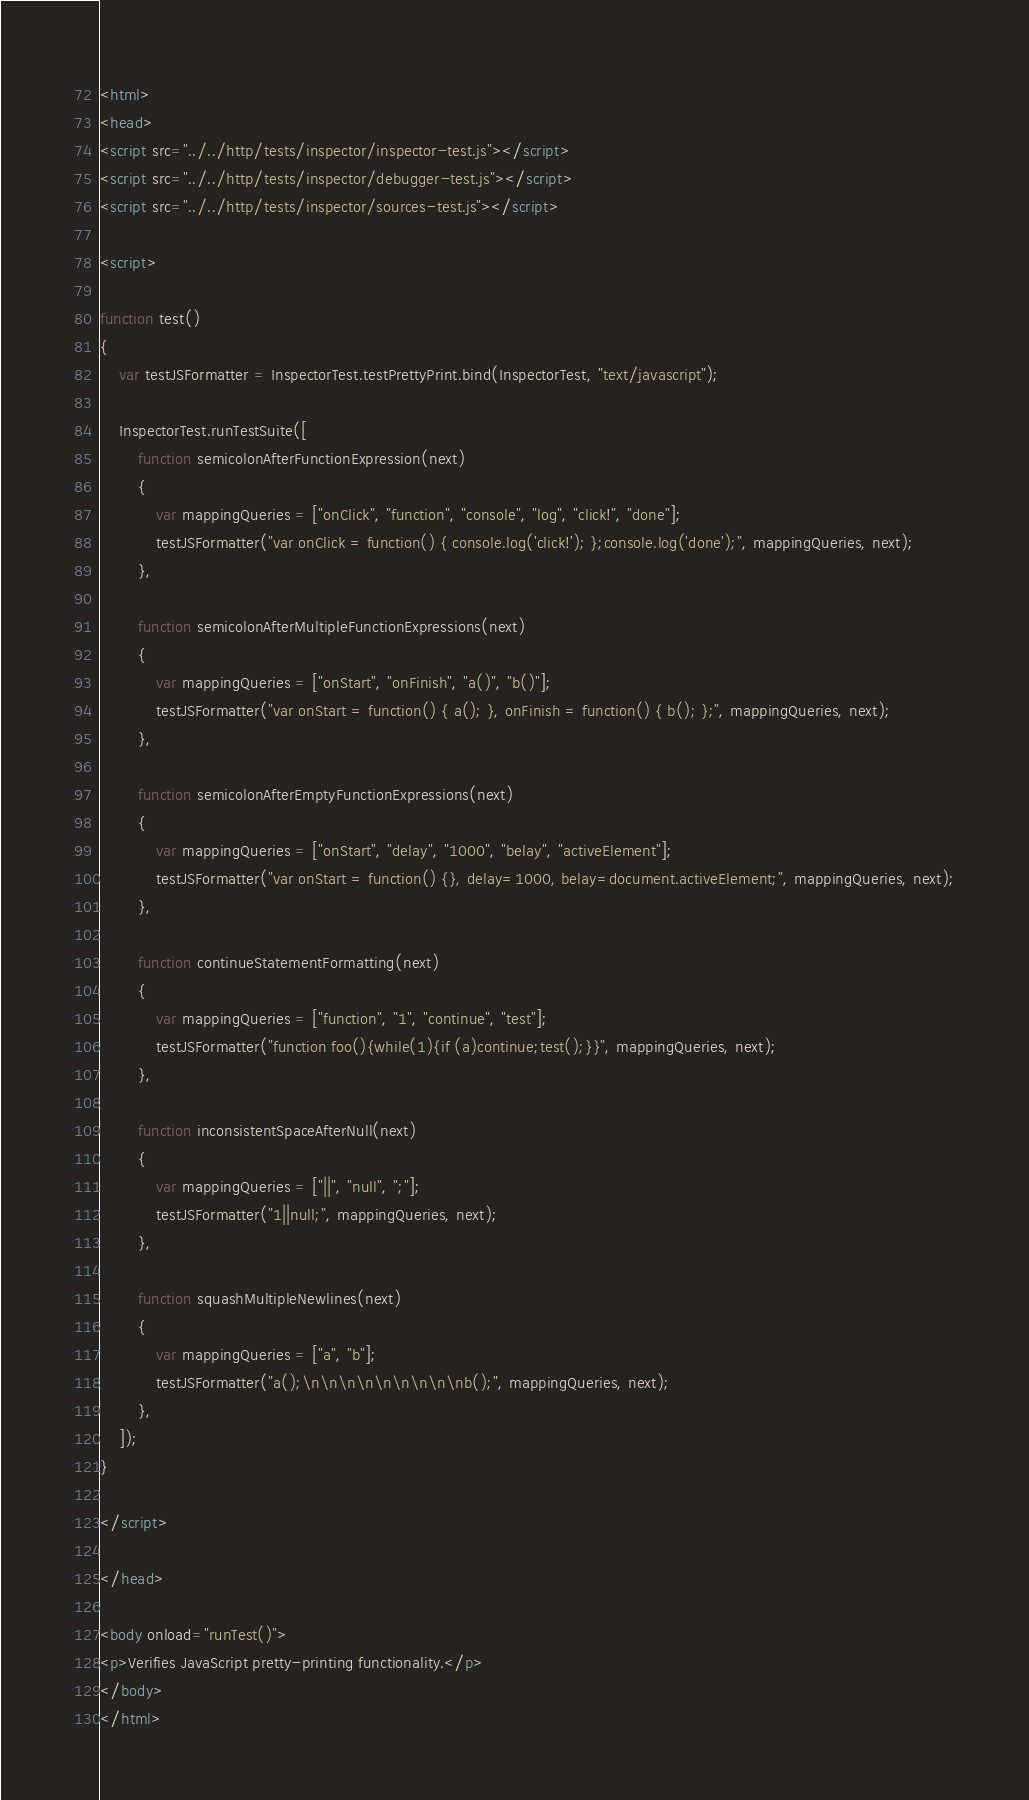<code> <loc_0><loc_0><loc_500><loc_500><_HTML_><html>
<head>
<script src="../../http/tests/inspector/inspector-test.js"></script>
<script src="../../http/tests/inspector/debugger-test.js"></script>
<script src="../../http/tests/inspector/sources-test.js"></script>

<script>

function test()
{
    var testJSFormatter = InspectorTest.testPrettyPrint.bind(InspectorTest, "text/javascript");

    InspectorTest.runTestSuite([
        function semicolonAfterFunctionExpression(next)
        {
            var mappingQueries = ["onClick", "function", "console", "log", "click!", "done"];
            testJSFormatter("var onClick = function() { console.log('click!'); };console.log('done');", mappingQueries, next);
        },

        function semicolonAfterMultipleFunctionExpressions(next)
        {
            var mappingQueries = ["onStart", "onFinish", "a()", "b()"];
            testJSFormatter("var onStart = function() { a(); }, onFinish = function() { b(); };", mappingQueries, next);
        },

        function semicolonAfterEmptyFunctionExpressions(next)
        {
            var mappingQueries = ["onStart", "delay", "1000", "belay", "activeElement"];
            testJSFormatter("var onStart = function() {}, delay=1000, belay=document.activeElement;", mappingQueries, next);
        },

        function continueStatementFormatting(next)
        {
            var mappingQueries = ["function", "1", "continue", "test"];
            testJSFormatter("function foo(){while(1){if (a)continue;test();}}", mappingQueries, next);
        },

        function inconsistentSpaceAfterNull(next)
        {
            var mappingQueries = ["||", "null", ";"];
            testJSFormatter("1||null;", mappingQueries, next);
        },

        function squashMultipleNewlines(next)
        {
            var mappingQueries = ["a", "b"];
            testJSFormatter("a();\n\n\n\n\n\n\n\n\nb();", mappingQueries, next);
        },
    ]);
}

</script>

</head>

<body onload="runTest()">
<p>Verifies JavaScript pretty-printing functionality.</p>
</body>
</html>
</code> 